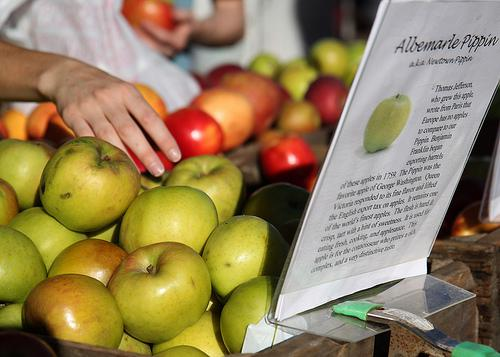Question: what fruit is there?
Choices:
A. Apples.
B. Bananas.
C. Grapes.
D. Mangoes.
Answer with the letter. Answer: A Question: how many different color apples are there?
Choices:
A. Two.
B. Three.
C. One.
D. None.
Answer with the letter. Answer: A 